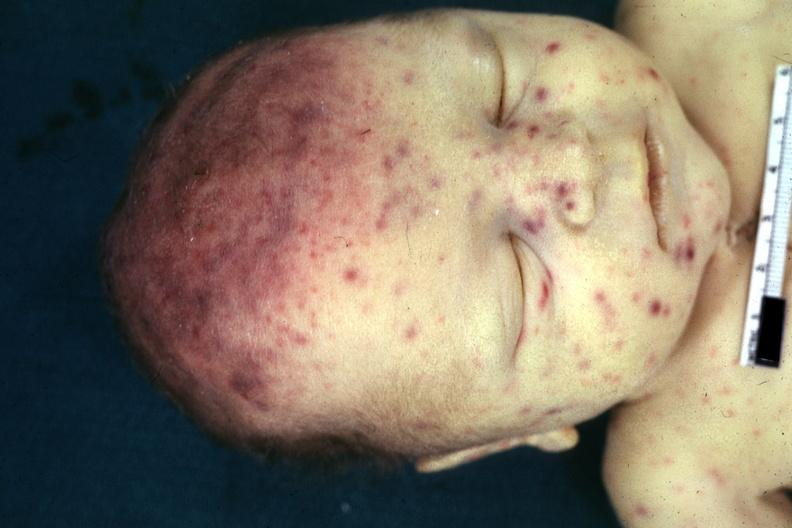what is present?
Answer the question using a single word or phrase. Cytomegalic inclusion virus infection in infant 